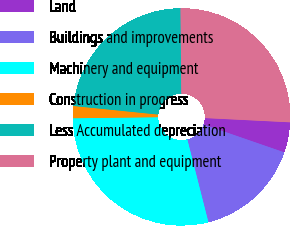Convert chart. <chart><loc_0><loc_0><loc_500><loc_500><pie_chart><fcel>Land<fcel>Buildings and improvements<fcel>Machinery and equipment<fcel>Construction in progress<fcel>Less Accumulated depreciation<fcel>Property plant and equipment<nl><fcel>4.5%<fcel>15.74%<fcel>28.77%<fcel>1.8%<fcel>23.24%<fcel>25.94%<nl></chart> 